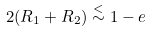<formula> <loc_0><loc_0><loc_500><loc_500>2 ( R _ { 1 } + R _ { 2 } ) \stackrel { < } { \sim } 1 - e</formula> 